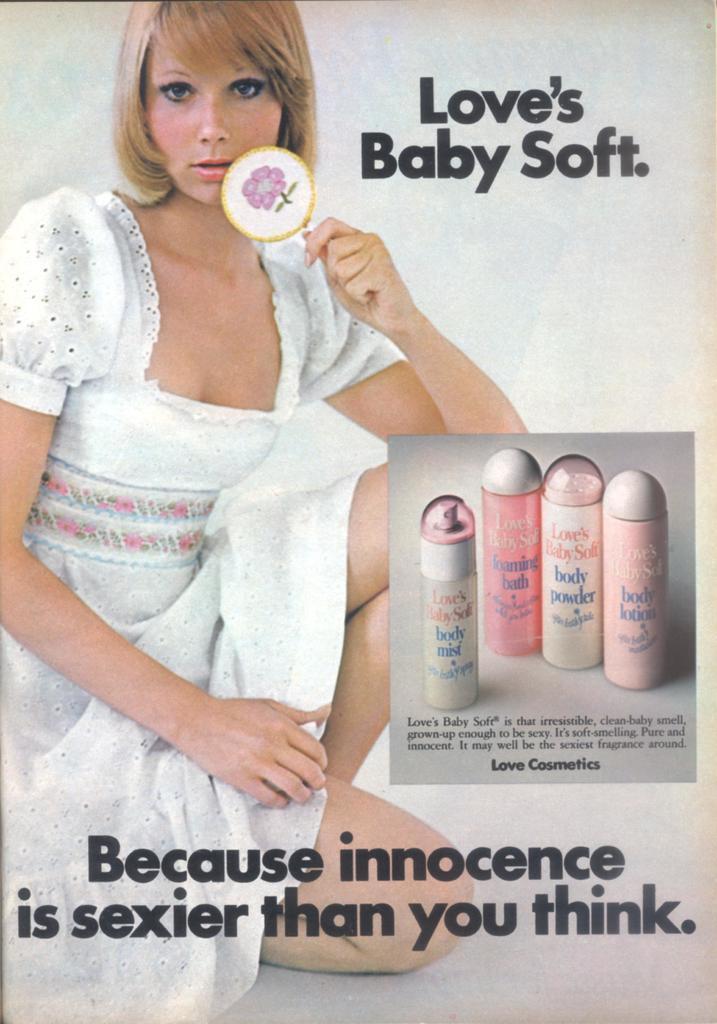In one or two sentences, can you explain what this image depicts? In this image there is an edited image in which there are some texts written on the image and there is a woman sitting. 